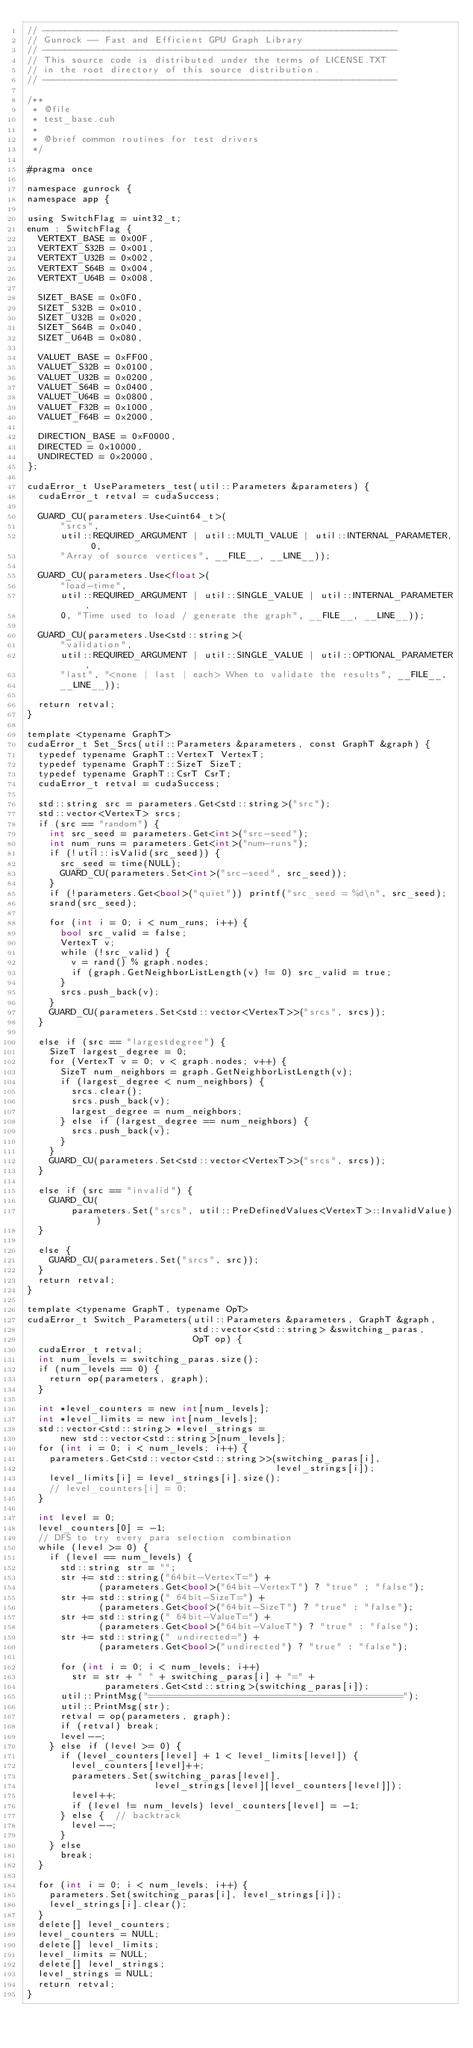Convert code to text. <code><loc_0><loc_0><loc_500><loc_500><_Cuda_>// ----------------------------------------------------------------
// Gunrock -- Fast and Efficient GPU Graph Library
// ----------------------------------------------------------------
// This source code is distributed under the terms of LICENSE.TXT
// in the root directory of this source distribution.
// ----------------------------------------------------------------

/**
 * @file
 * test_base.cuh
 *
 * @brief common routines for test drivers
 */

#pragma once

namespace gunrock {
namespace app {

using SwitchFlag = uint32_t;
enum : SwitchFlag {
  VERTEXT_BASE = 0x00F,
  VERTEXT_S32B = 0x001,
  VERTEXT_U32B = 0x002,
  VERTEXT_S64B = 0x004,
  VERTEXT_U64B = 0x008,

  SIZET_BASE = 0x0F0,
  SIZET_S32B = 0x010,
  SIZET_U32B = 0x020,
  SIZET_S64B = 0x040,
  SIZET_U64B = 0x080,

  VALUET_BASE = 0xFF00,
  VALUET_S32B = 0x0100,
  VALUET_U32B = 0x0200,
  VALUET_S64B = 0x0400,
  VALUET_U64B = 0x0800,
  VALUET_F32B = 0x1000,
  VALUET_F64B = 0x2000,

  DIRECTION_BASE = 0xF0000,
  DIRECTED = 0x10000,
  UNDIRECTED = 0x20000,
};

cudaError_t UseParameters_test(util::Parameters &parameters) {
  cudaError_t retval = cudaSuccess;

  GUARD_CU(parameters.Use<uint64_t>(
      "srcs",
      util::REQUIRED_ARGUMENT | util::MULTI_VALUE | util::INTERNAL_PARAMETER, 0,
      "Array of source vertices", __FILE__, __LINE__));

  GUARD_CU(parameters.Use<float>(
      "load-time",
      util::REQUIRED_ARGUMENT | util::SINGLE_VALUE | util::INTERNAL_PARAMETER,
      0, "Time used to load / generate the graph", __FILE__, __LINE__));

  GUARD_CU(parameters.Use<std::string>(
      "validation",
      util::REQUIRED_ARGUMENT | util::SINGLE_VALUE | util::OPTIONAL_PARAMETER,
      "last", "<none | last | each> When to validate the results", __FILE__,
      __LINE__));

  return retval;
}

template <typename GraphT>
cudaError_t Set_Srcs(util::Parameters &parameters, const GraphT &graph) {
  typedef typename GraphT::VertexT VertexT;
  typedef typename GraphT::SizeT SizeT;
  typedef typename GraphT::CsrT CsrT;
  cudaError_t retval = cudaSuccess;

  std::string src = parameters.Get<std::string>("src");
  std::vector<VertexT> srcs;
  if (src == "random") {
    int src_seed = parameters.Get<int>("src-seed");
    int num_runs = parameters.Get<int>("num-runs");
    if (!util::isValid(src_seed)) {
      src_seed = time(NULL);
      GUARD_CU(parameters.Set<int>("src-seed", src_seed));
    }
    if (!parameters.Get<bool>("quiet")) printf("src_seed = %d\n", src_seed);
    srand(src_seed);

    for (int i = 0; i < num_runs; i++) {
      bool src_valid = false;
      VertexT v;
      while (!src_valid) {
        v = rand() % graph.nodes;
        if (graph.GetNeighborListLength(v) != 0) src_valid = true;
      }
      srcs.push_back(v);
    }
    GUARD_CU(parameters.Set<std::vector<VertexT>>("srcs", srcs));
  }

  else if (src == "largestdegree") {
    SizeT largest_degree = 0;
    for (VertexT v = 0; v < graph.nodes; v++) {
      SizeT num_neighbors = graph.GetNeighborListLength(v);
      if (largest_degree < num_neighbors) {
        srcs.clear();
        srcs.push_back(v);
        largest_degree = num_neighbors;
      } else if (largest_degree == num_neighbors) {
        srcs.push_back(v);
      }
    }
    GUARD_CU(parameters.Set<std::vector<VertexT>>("srcs", srcs));
  }

  else if (src == "invalid") {
    GUARD_CU(
        parameters.Set("srcs", util::PreDefinedValues<VertexT>::InvalidValue))
  }

  else {
    GUARD_CU(parameters.Set("srcs", src));
  }
  return retval;
}

template <typename GraphT, typename OpT>
cudaError_t Switch_Parameters(util::Parameters &parameters, GraphT &graph,
                              std::vector<std::string> &switching_paras,
                              OpT op) {
  cudaError_t retval;
  int num_levels = switching_paras.size();
  if (num_levels == 0) {
    return op(parameters, graph);
  }

  int *level_counters = new int[num_levels];
  int *level_limits = new int[num_levels];
  std::vector<std::string> *level_strings =
      new std::vector<std::string>[num_levels];
  for (int i = 0; i < num_levels; i++) {
    parameters.Get<std::vector<std::string>>(switching_paras[i],
                                             level_strings[i]);
    level_limits[i] = level_strings[i].size();
    // level_counters[i] = 0;
  }

  int level = 0;
  level_counters[0] = -1;
  // DFS to try every para selection combination
  while (level >= 0) {
    if (level == num_levels) {
      std::string str = "";
      str += std::string("64bit-VertexT=") +
             (parameters.Get<bool>("64bit-VertexT") ? "true" : "false");
      str += std::string(" 64bit-SizeT=") +
             (parameters.Get<bool>("64bit-SizeT") ? "true" : "false");
      str += std::string(" 64bit-ValueT=") +
             (parameters.Get<bool>("64bit-ValueT") ? "true" : "false");
      str += std::string(" undirected=") +
             (parameters.Get<bool>("undirected") ? "true" : "false");

      for (int i = 0; i < num_levels; i++)
        str = str + " " + switching_paras[i] + "=" +
              parameters.Get<std::string>(switching_paras[i]);
      util::PrintMsg("==============================================");
      util::PrintMsg(str);
      retval = op(parameters, graph);
      if (retval) break;
      level--;
    } else if (level >= 0) {
      if (level_counters[level] + 1 < level_limits[level]) {
        level_counters[level]++;
        parameters.Set(switching_paras[level],
                       level_strings[level][level_counters[level]]);
        level++;
        if (level != num_levels) level_counters[level] = -1;
      } else {  // backtrack
        level--;
      }
    } else
      break;
  }

  for (int i = 0; i < num_levels; i++) {
    parameters.Set(switching_paras[i], level_strings[i]);
    level_strings[i].clear();
  }
  delete[] level_counters;
  level_counters = NULL;
  delete[] level_limits;
  level_limits = NULL;
  delete[] level_strings;
  level_strings = NULL;
  return retval;
}
</code> 